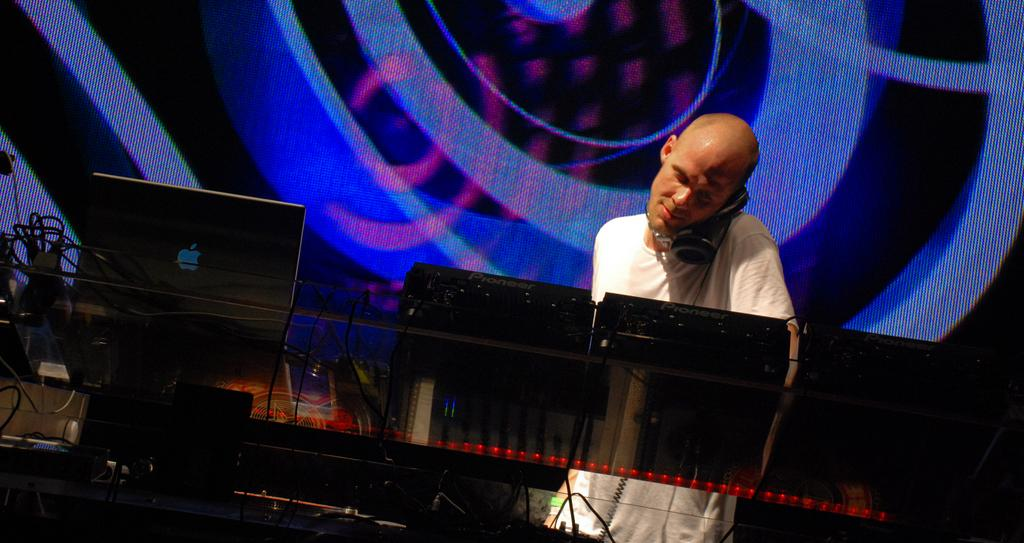What is the main subject of the image? There is a person standing in the image. What electronic device is visible in the image? There is a laptop in the image. Are there any other electronic gadgets present in the image? Yes, there are electronic gadgets in the image. What color is the background of the image? The background of the image is blue. How many ladybugs can be seen on the laptop in the image? There are no ladybugs present in the image, as it features a person and electronic devices. 